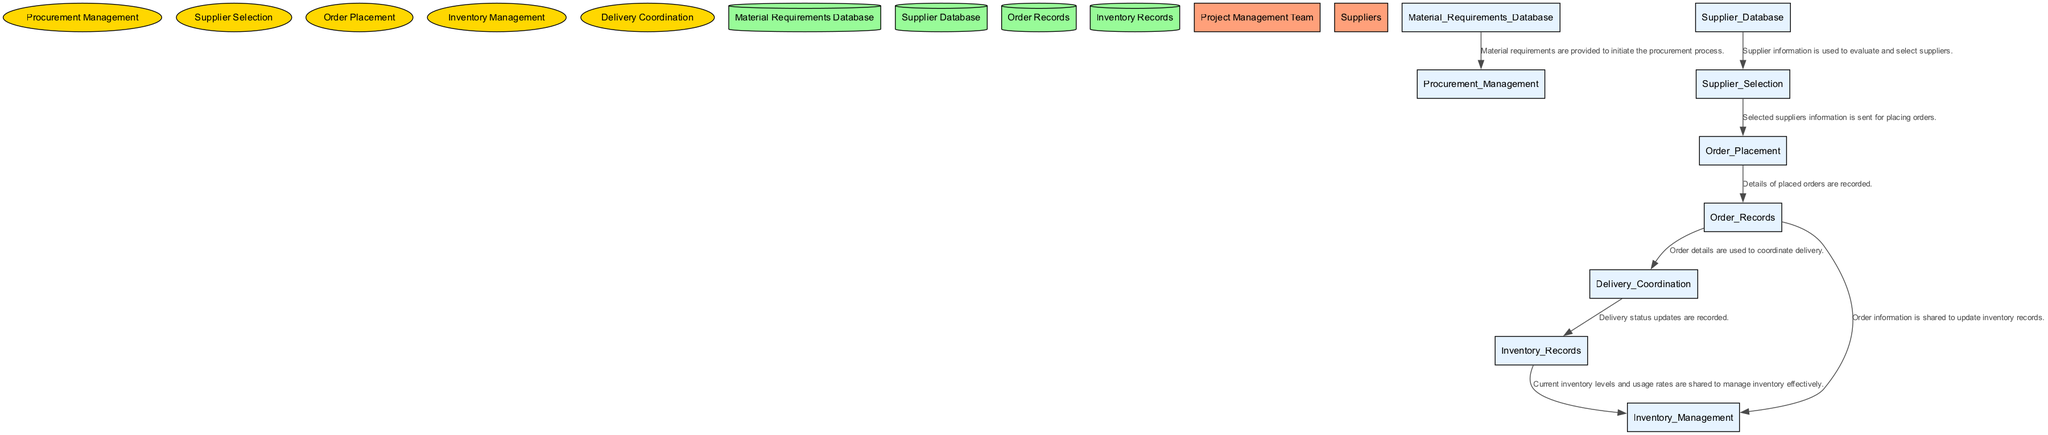What is the first process in the diagram? The first process listed in the diagram is "Procurement Management" which begins the procurement actions based on the material requirements.
Answer: Procurement Management How many processes are depicted in the diagram? There are five processes shown in the diagram related to the procurement and delivery of construction materials for the bridge project.
Answer: Five What data flow connects the "Order Placement" to "Order Records"? The data flow connecting "Order Placement" to "Order Records" is labeled "Details of placed orders are recorded," indicating that order placement results in an updated record of orders.
Answer: Details of placed orders are recorded Which external entity interacts with the "Supplier Selection" process? The external entity that interacts with the "Supplier Selection" process is "Suppliers," who provide the necessary information to evaluate and select the appropriate suppliers.
Answer: Suppliers What action does "Delivery Coordination" take after receiving information from "Order Records"? After receiving information from "Order Records," "Delivery Coordination" uses the order details to ensure that materials are delivered to the construction site as scheduled.
Answer: Coordinates delivery What is the purpose of the "Inventory Management" process? The purpose of the "Inventory Management" process is to monitor and manage the stock of materials at the construction site, ensuring that material levels are adequate for construction needs.
Answer: Manage stock Which data store keeps records of all placed orders? The data store that keeps records of all placed orders is labeled "Order Records," which contains details about the orders including dates, quantities, and delivery schedules.
Answer: Order Records How many data flows are present in the diagram? There are eight distinct data flows represented in the diagram, each connecting various processes and data stores.
Answer: Eight What information does the "Material Requirements Database" provide to the procurement process? The "Material Requirements Database" provides the material requirements that are needed to initiate the procurement process, facilitating the procurement activities.
Answer: Material requirements 